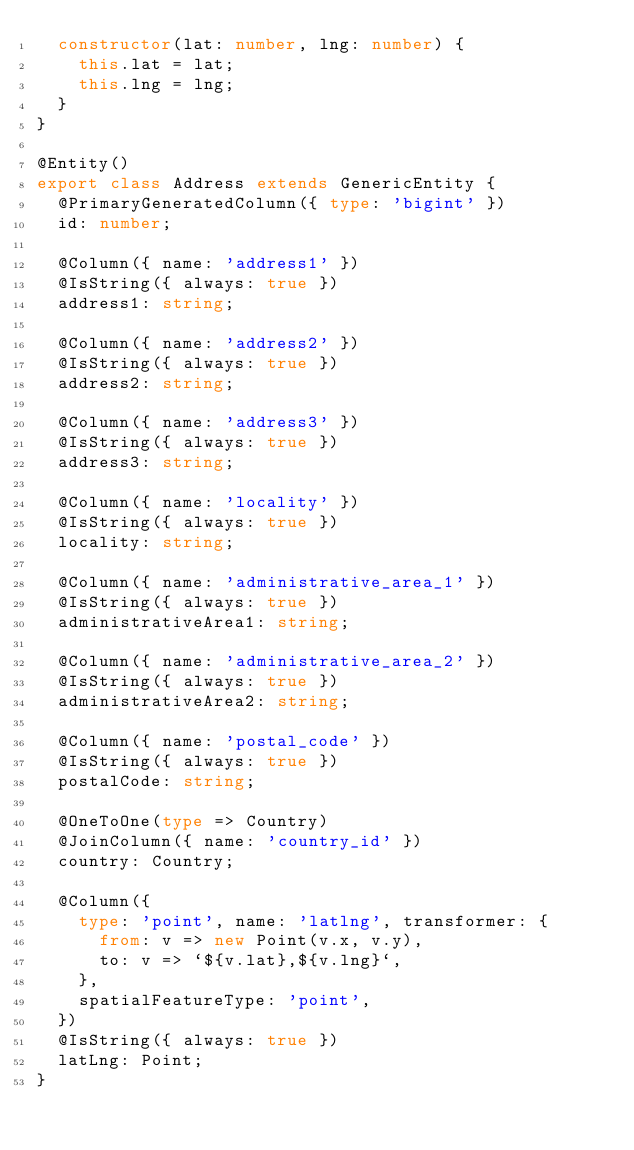Convert code to text. <code><loc_0><loc_0><loc_500><loc_500><_TypeScript_>  constructor(lat: number, lng: number) {
    this.lat = lat;
    this.lng = lng;
  }
}

@Entity()
export class Address extends GenericEntity {
  @PrimaryGeneratedColumn({ type: 'bigint' })
  id: number;

  @Column({ name: 'address1' })
  @IsString({ always: true })
  address1: string;

  @Column({ name: 'address2' })
  @IsString({ always: true })
  address2: string;

  @Column({ name: 'address3' })
  @IsString({ always: true })
  address3: string;

  @Column({ name: 'locality' })
  @IsString({ always: true })
  locality: string;

  @Column({ name: 'administrative_area_1' })
  @IsString({ always: true })
  administrativeArea1: string;

  @Column({ name: 'administrative_area_2' })
  @IsString({ always: true })
  administrativeArea2: string;

  @Column({ name: 'postal_code' })
  @IsString({ always: true })
  postalCode: string;

  @OneToOne(type => Country)
  @JoinColumn({ name: 'country_id' })
  country: Country;

  @Column({
    type: 'point', name: 'latlng', transformer: {
      from: v => new Point(v.x, v.y),
      to: v => `${v.lat},${v.lng}`,
    },
    spatialFeatureType: 'point',
  })
  @IsString({ always: true })
  latLng: Point;
}
</code> 